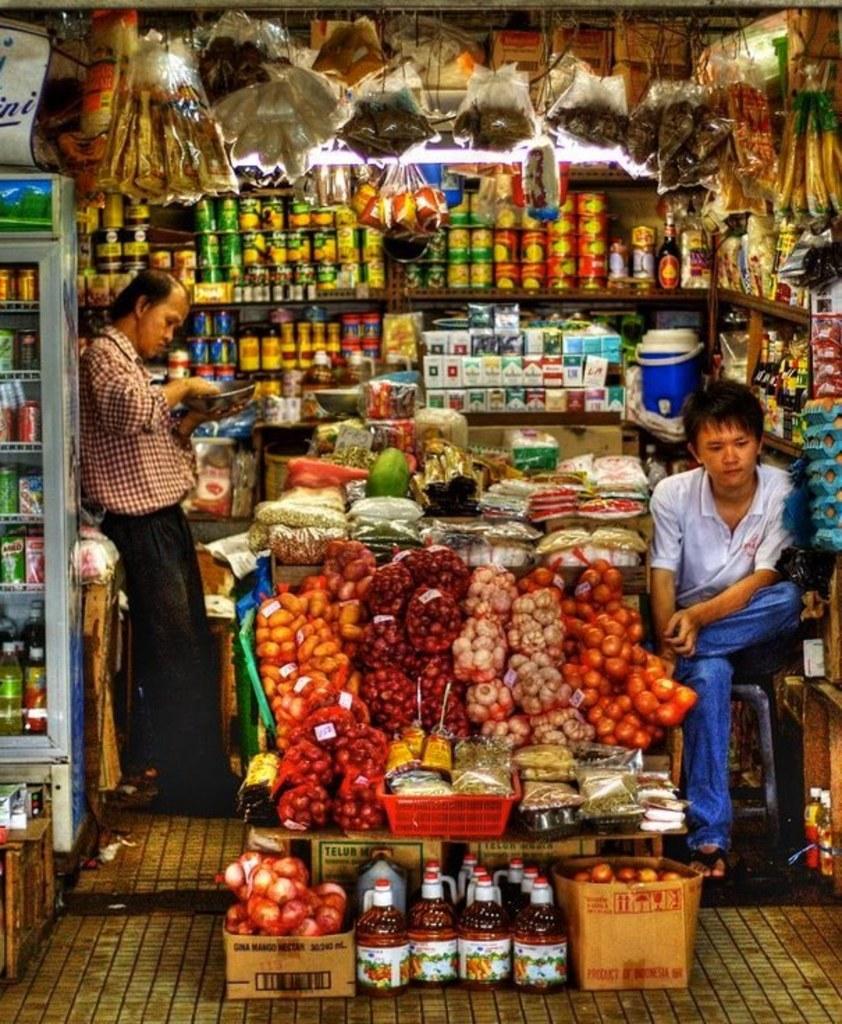In one or two sentences, can you explain what this image depicts? In the foreground of this image, there are many objects in the shop, few beverages in the fridge, few items hanging on the top, a man sitting on the stool, a man standing. 